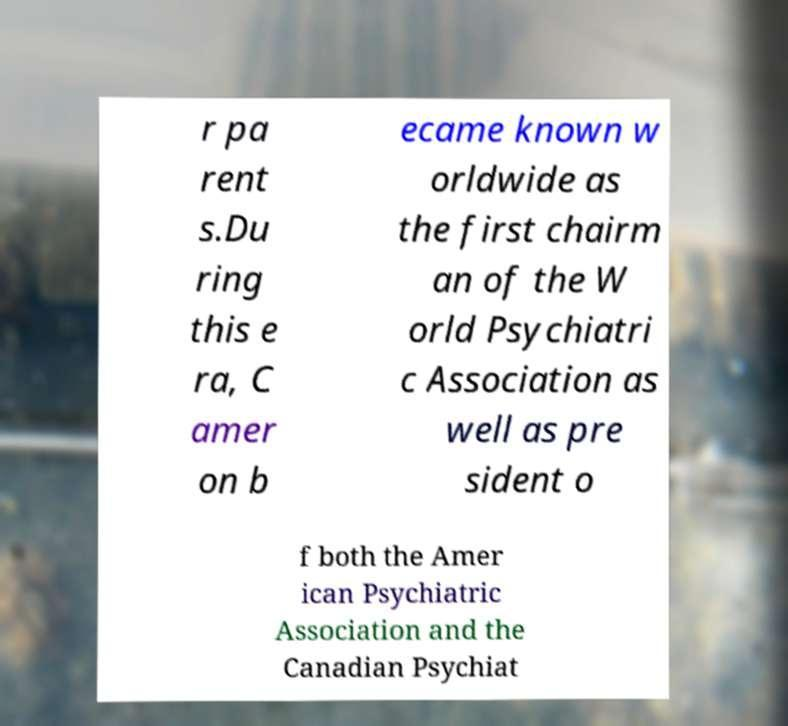I need the written content from this picture converted into text. Can you do that? r pa rent s.Du ring this e ra, C amer on b ecame known w orldwide as the first chairm an of the W orld Psychiatri c Association as well as pre sident o f both the Amer ican Psychiatric Association and the Canadian Psychiat 